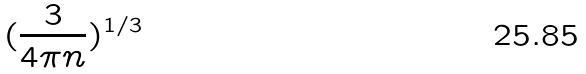<formula> <loc_0><loc_0><loc_500><loc_500>( \frac { 3 } { 4 \pi n } ) ^ { 1 / 3 }</formula> 